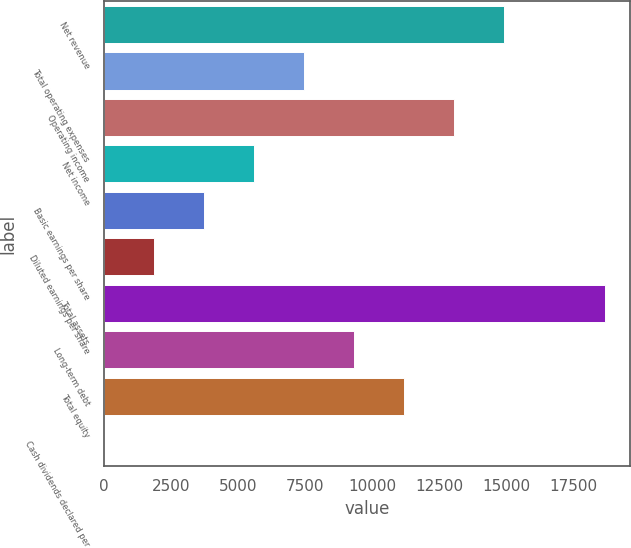Convert chart to OTSL. <chart><loc_0><loc_0><loc_500><loc_500><bar_chart><fcel>Net revenue<fcel>Total operating expenses<fcel>Operating income<fcel>Net income<fcel>Basic earnings per share<fcel>Diluted earnings per share<fcel>Total assets<fcel>Long-term debt<fcel>Total equity<fcel>Cash dividends declared per<nl><fcel>14940.1<fcel>7470.47<fcel>13072.7<fcel>5603.05<fcel>3735.63<fcel>1868.21<fcel>18675<fcel>9337.89<fcel>11205.3<fcel>0.79<nl></chart> 